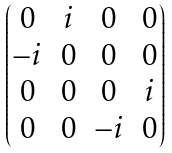<formula> <loc_0><loc_0><loc_500><loc_500>\begin{pmatrix} 0 & i & 0 & 0 \\ - i & 0 & 0 & 0 \\ 0 & 0 & 0 & i \\ 0 & 0 & - i & 0 \end{pmatrix}</formula> 